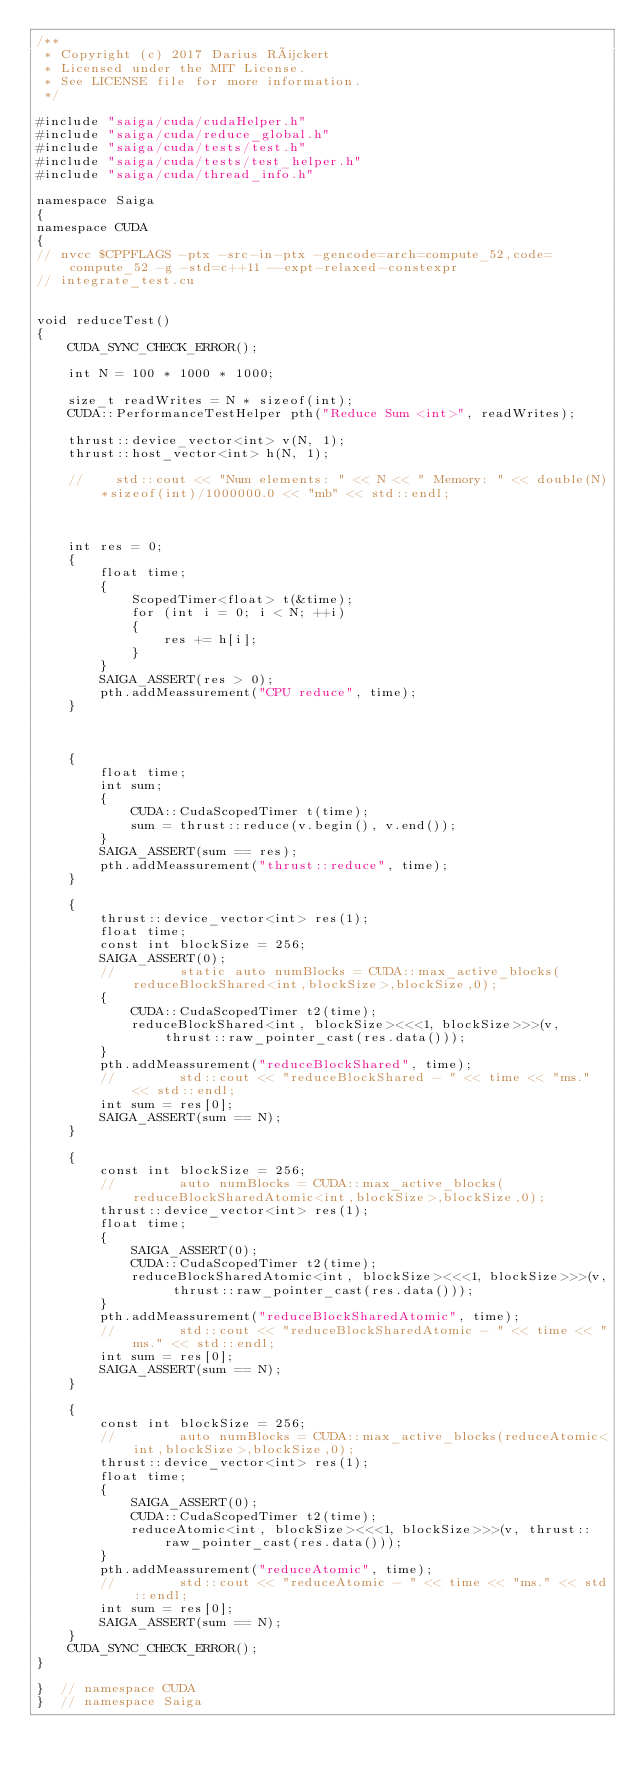Convert code to text. <code><loc_0><loc_0><loc_500><loc_500><_Cuda_>/**
 * Copyright (c) 2017 Darius Rückert
 * Licensed under the MIT License.
 * See LICENSE file for more information.
 */

#include "saiga/cuda/cudaHelper.h"
#include "saiga/cuda/reduce_global.h"
#include "saiga/cuda/tests/test.h"
#include "saiga/cuda/tests/test_helper.h"
#include "saiga/cuda/thread_info.h"

namespace Saiga
{
namespace CUDA
{
// nvcc $CPPFLAGS -ptx -src-in-ptx -gencode=arch=compute_52,code=compute_52 -g -std=c++11 --expt-relaxed-constexpr
// integrate_test.cu


void reduceTest()
{
    CUDA_SYNC_CHECK_ERROR();

    int N = 100 * 1000 * 1000;

    size_t readWrites = N * sizeof(int);
    CUDA::PerformanceTestHelper pth("Reduce Sum <int>", readWrites);

    thrust::device_vector<int> v(N, 1);
    thrust::host_vector<int> h(N, 1);

    //    std::cout << "Num elements: " << N << " Memory: " << double(N)*sizeof(int)/1000000.0 << "mb" << std::endl;



    int res = 0;
    {
        float time;
        {
            ScopedTimer<float> t(&time);
            for (int i = 0; i < N; ++i)
            {
                res += h[i];
            }
        }
        SAIGA_ASSERT(res > 0);
        pth.addMeassurement("CPU reduce", time);
    }



    {
        float time;
        int sum;
        {
            CUDA::CudaScopedTimer t(time);
            sum = thrust::reduce(v.begin(), v.end());
        }
        SAIGA_ASSERT(sum == res);
        pth.addMeassurement("thrust::reduce", time);
    }

    {
        thrust::device_vector<int> res(1);
        float time;
        const int blockSize = 256;
        SAIGA_ASSERT(0);
        //        static auto numBlocks = CUDA::max_active_blocks(reduceBlockShared<int,blockSize>,blockSize,0);
        {
            CUDA::CudaScopedTimer t2(time);
            reduceBlockShared<int, blockSize><<<1, blockSize>>>(v, thrust::raw_pointer_cast(res.data()));
        }
        pth.addMeassurement("reduceBlockShared", time);
        //        std::cout << "reduceBlockShared - " << time << "ms." << std::endl;
        int sum = res[0];
        SAIGA_ASSERT(sum == N);
    }

    {
        const int blockSize = 256;
        //        auto numBlocks = CUDA::max_active_blocks(reduceBlockSharedAtomic<int,blockSize>,blockSize,0);
        thrust::device_vector<int> res(1);
        float time;
        {
            SAIGA_ASSERT(0);
            CUDA::CudaScopedTimer t2(time);
            reduceBlockSharedAtomic<int, blockSize><<<1, blockSize>>>(v, thrust::raw_pointer_cast(res.data()));
        }
        pth.addMeassurement("reduceBlockSharedAtomic", time);
        //        std::cout << "reduceBlockSharedAtomic - " << time << "ms." << std::endl;
        int sum = res[0];
        SAIGA_ASSERT(sum == N);
    }

    {
        const int blockSize = 256;
        //        auto numBlocks = CUDA::max_active_blocks(reduceAtomic<int,blockSize>,blockSize,0);
        thrust::device_vector<int> res(1);
        float time;
        {
            SAIGA_ASSERT(0);
            CUDA::CudaScopedTimer t2(time);
            reduceAtomic<int, blockSize><<<1, blockSize>>>(v, thrust::raw_pointer_cast(res.data()));
        }
        pth.addMeassurement("reduceAtomic", time);
        //        std::cout << "reduceAtomic - " << time << "ms." << std::endl;
        int sum = res[0];
        SAIGA_ASSERT(sum == N);
    }
    CUDA_SYNC_CHECK_ERROR();
}

}  // namespace CUDA
}  // namespace Saiga
</code> 